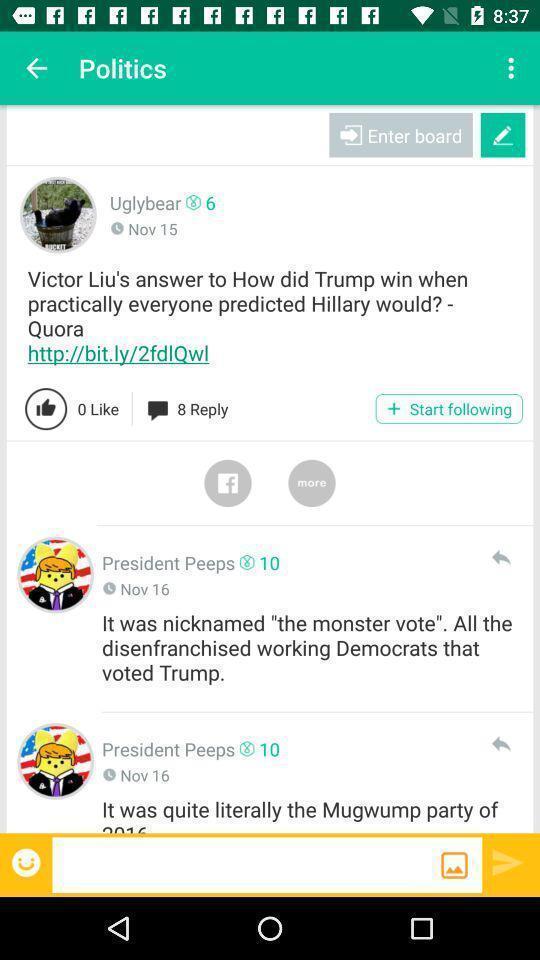Provide a textual representation of this image. Screen showing politics. 